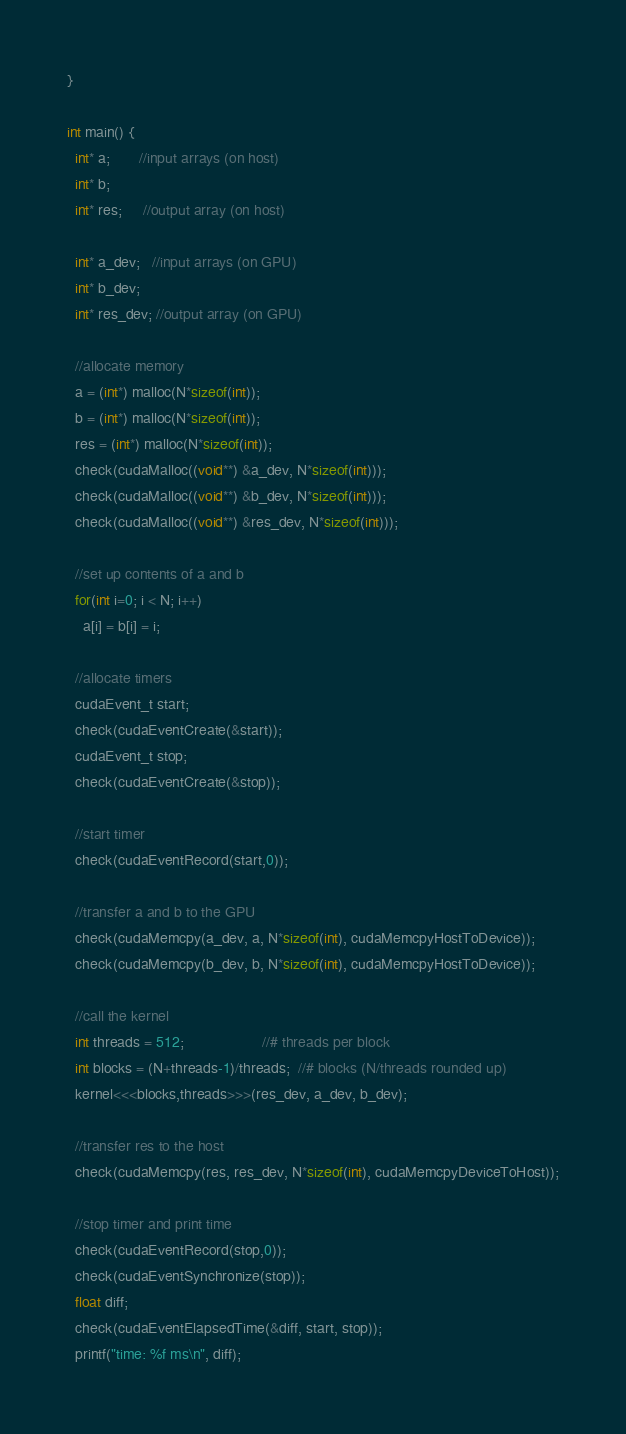Convert code to text. <code><loc_0><loc_0><loc_500><loc_500><_Cuda_>}

int main() {
  int* a;       //input arrays (on host)
  int* b;
  int* res;     //output array (on host)

  int* a_dev;   //input arrays (on GPU)
  int* b_dev;
  int* res_dev; //output array (on GPU) 

  //allocate memory
  a = (int*) malloc(N*sizeof(int));
  b = (int*) malloc(N*sizeof(int));
  res = (int*) malloc(N*sizeof(int));
  check(cudaMalloc((void**) &a_dev, N*sizeof(int)));
  check(cudaMalloc((void**) &b_dev, N*sizeof(int)));
  check(cudaMalloc((void**) &res_dev, N*sizeof(int)));

  //set up contents of a and b
  for(int i=0; i < N; i++)
    a[i] = b[i] = i;

  //allocate timers
  cudaEvent_t start;
  check(cudaEventCreate(&start));
  cudaEvent_t stop;
  check(cudaEventCreate(&stop));

  //start timer
  check(cudaEventRecord(start,0));

  //transfer a and b to the GPU
  check(cudaMemcpy(a_dev, a, N*sizeof(int), cudaMemcpyHostToDevice));
  check(cudaMemcpy(b_dev, b, N*sizeof(int), cudaMemcpyHostToDevice));

  //call the kernel
  int threads = 512;                   //# threads per block
  int blocks = (N+threads-1)/threads;  //# blocks (N/threads rounded up)
  kernel<<<blocks,threads>>>(res_dev, a_dev, b_dev);

  //transfer res to the host
  check(cudaMemcpy(res, res_dev, N*sizeof(int), cudaMemcpyDeviceToHost));

  //stop timer and print time
  check(cudaEventRecord(stop,0));
  check(cudaEventSynchronize(stop));
  float diff;
  check(cudaEventElapsedTime(&diff, start, stop));
  printf("time: %f ms\n", diff);
</code> 